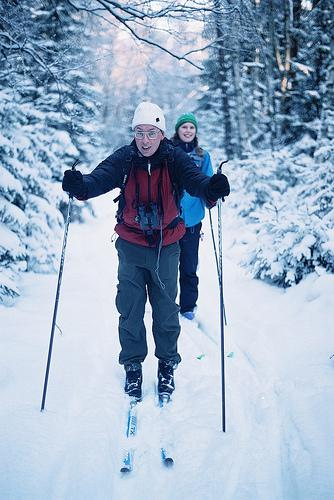Question: what are they holding?
Choices:
A. Sticks.
B. Poles.
C. Ladder.
D. Phone.
Answer with the letter. Answer: B Question: who is in front?
Choices:
A. A lady.
B. A girl.
C. A man.
D. A boy.
Answer with the letter. Answer: C Question: where are they skiing?
Choices:
A. Up the hill.
B. Down the slope.
C. Down a trail.
D. In the mountains.
Answer with the letter. Answer: C 